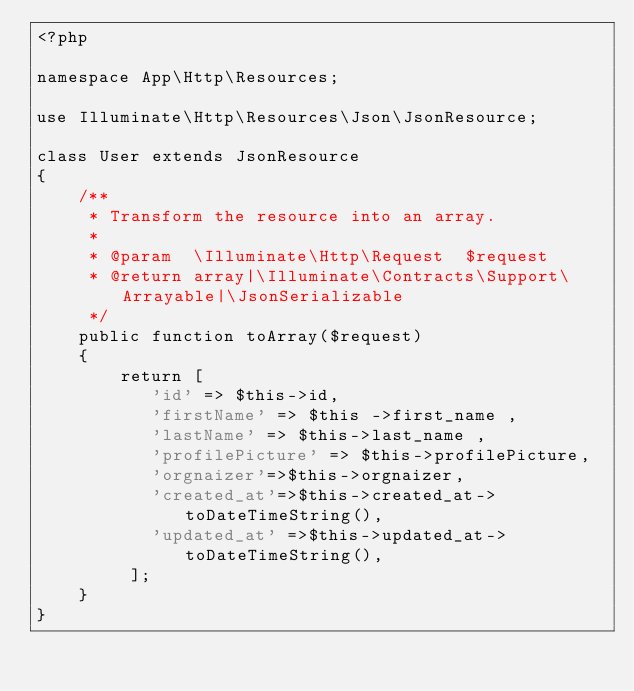Convert code to text. <code><loc_0><loc_0><loc_500><loc_500><_PHP_><?php

namespace App\Http\Resources;

use Illuminate\Http\Resources\Json\JsonResource;

class User extends JsonResource
{
    /**
     * Transform the resource into an array.
     *
     * @param  \Illuminate\Http\Request  $request
     * @return array|\Illuminate\Contracts\Support\Arrayable|\JsonSerializable
     */
    public function toArray($request)
    {
        return [
           'id' => $this->id,
           'firstName' => $this ->first_name ,
           'lastName' => $this->last_name ,
           'profilePicture' => $this->profilePicture,
           'orgnaizer'=>$this->orgnaizer,
           'created_at'=>$this->created_at->toDateTimeString(),
           'updated_at' =>$this->updated_at->toDateTimeString(),
         ];
    }
}
</code> 